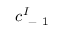<formula> <loc_0><loc_0><loc_500><loc_500>c _ { - 1 } ^ { I }</formula> 